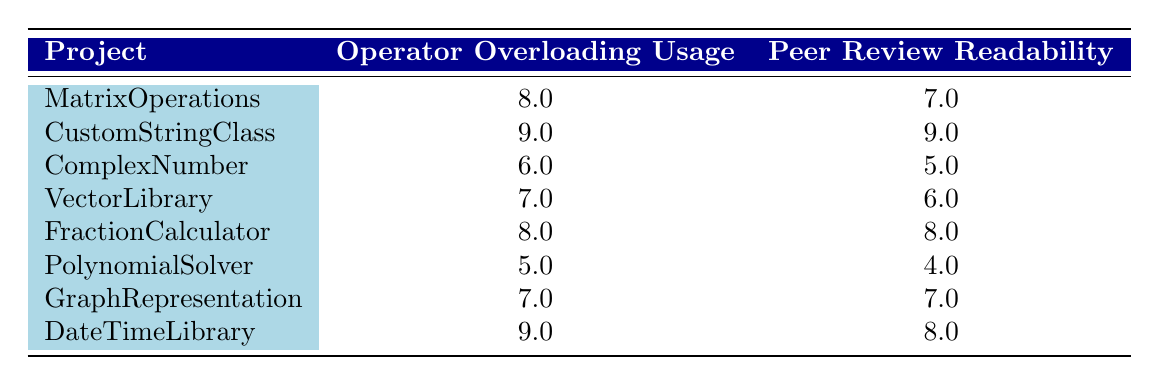What is the Operator Overloading Usage Score of the CustomStringClass project? The table lists the Operator Overloading Usage Score for each project, and for the CustomStringClass, the score is explicitly provided as 9.
Answer: 9 What is the Peer Review Readability Score for the PolynomialSolver project? Looking at the table, we can see that the Peer Review Readability Score for the PolynomialSolver project is listed as 4.
Answer: 4 Which project has the highest Operator Overloading Usage Score and what is that score? By checking the Operator Overloading Usage Scores in the table, we find that the highest score is 9, which belongs to both CustomStringClass and DateTimeLibrary.
Answer: CustomStringClass and DateTimeLibrary, 9 What is the difference between the average Operator Overloading Usage Score and the average Peer Review Readability Score? First, we calculate the average Operator Overloading Usage Score: (8 + 9 + 6 + 7 + 8 + 5 + 7 + 9) / 8 = 7.5. Next, we calculate the average Peer Review Readability Score: (7 + 9 + 5 + 6 + 8 + 4 + 7 + 8) / 8 = 7.125. Now, subtract the average Peer Review Readability Score from the average Operator Overloading Usage Score: 7.5 - 7.125 = 0.375.
Answer: 0.375 Is it true that all projects with an Operator Overloading Usage Score above 7 also have a Peer Review Readability Score above 7? Checking the scores from the table, the projects with scores above 7 are CustomStringClass (9/9), FractionCalculator (8/8), and DateTimeLibrary (9/8). All these projects have a matching Peer Review Readability Score above 7, confirming the statement to be true.
Answer: Yes Which project has the lowest Peer Review Readability Score and what is that score? Scanning through the table, we find that the PolynomialSolver project has the lowest Peer Review Readability Score listed, which is 4.
Answer: PolynomialSolver, 4 How many projects have an Operator Overloading Usage Score of 7 or more? We can see that the projects with scores of 7 or above are MatrixOperations (8), CustomStringClass (9), FractionCalculator (8), GraphRepresentation (7), and DateTimeLibrary (9). Counting these, we find a total of 5 projects.
Answer: 5 